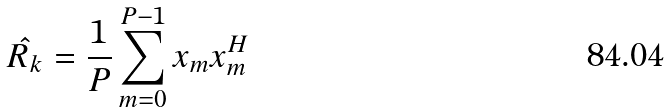Convert formula to latex. <formula><loc_0><loc_0><loc_500><loc_500>\hat { R _ { k } } = \frac { 1 } { P } \sum _ { m = 0 } ^ { P - 1 } x _ { m } x _ { m } ^ { H }</formula> 